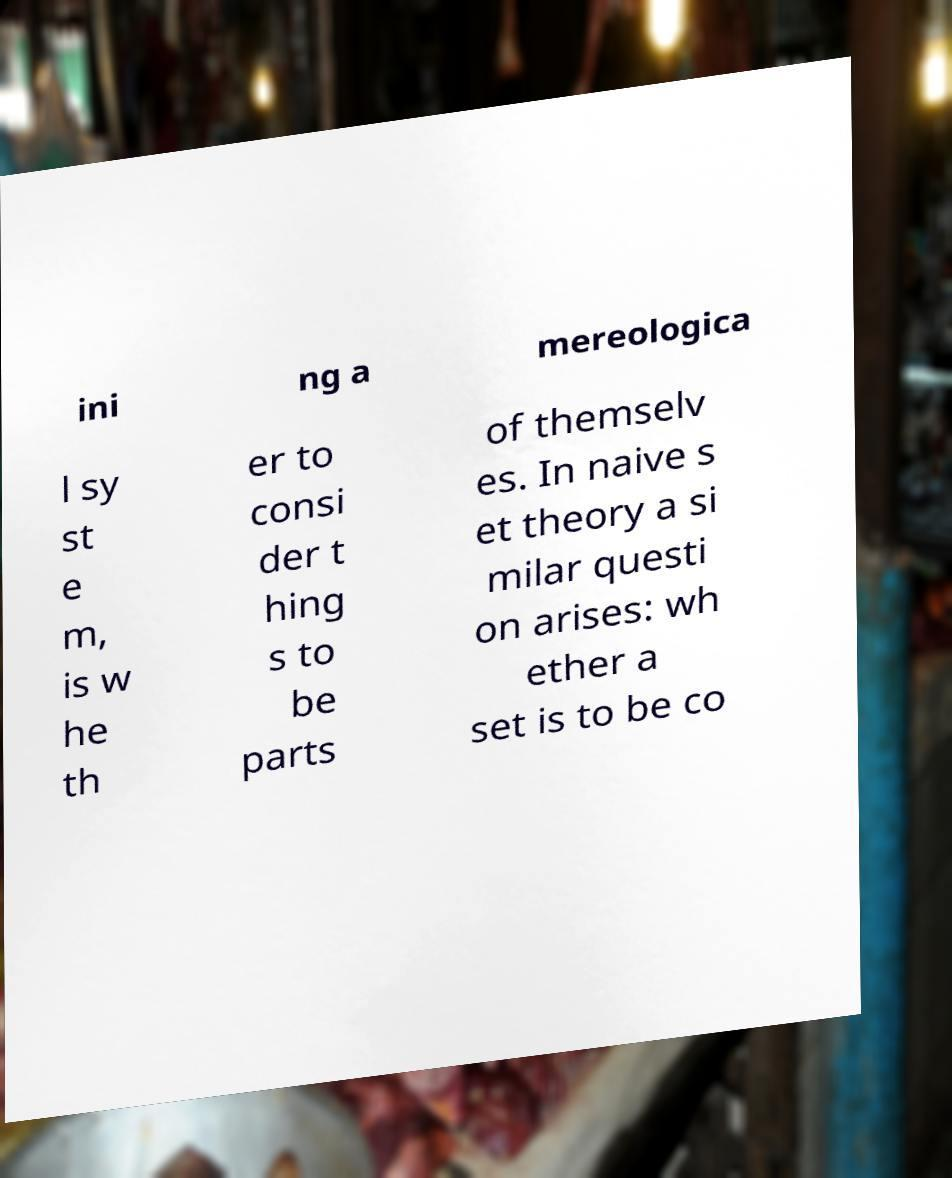Can you read and provide the text displayed in the image?This photo seems to have some interesting text. Can you extract and type it out for me? ini ng a mereologica l sy st e m, is w he th er to consi der t hing s to be parts of themselv es. In naive s et theory a si milar questi on arises: wh ether a set is to be co 